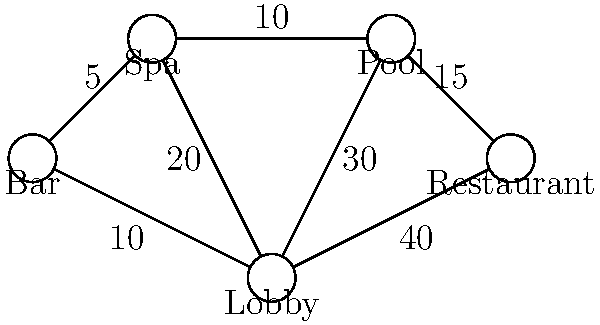Based on the guest flow topology diagram of your boutique hotel's common areas, what is the maximum flow from the Lobby to the Bar, and which path(s) contribute to this flow? To solve this problem, we'll use the concept of maximum flow in a network. Let's follow these steps:

1. Identify all possible paths from Lobby to Bar:
   a. Lobby -> Bar
   b. Lobby -> Spa -> Bar
   c. Lobby -> Pool -> Spa -> Bar
   d. Lobby -> Restaurant -> Pool -> Spa -> Bar

2. Calculate the flow for each path:
   a. Lobby -> Bar: 10
   b. Lobby -> Spa -> Bar: min(20, 5) = 5
   c. Lobby -> Pool -> Spa -> Bar: min(30, 10, 5) = 5
   d. Lobby -> Restaurant -> Pool -> Spa -> Bar: min(40, 15, 10, 5) = 5

3. Sum up the flows:
   Maximum flow = 10 + 5 = 15

The maximum flow is 15, achieved by combining the direct path (Lobby -> Bar) and one of the indirect paths. We choose the shortest indirect path (Lobby -> Spa -> Bar) to minimize congestion.
Answer: 15; Lobby -> Bar (10) and Lobby -> Spa -> Bar (5) 